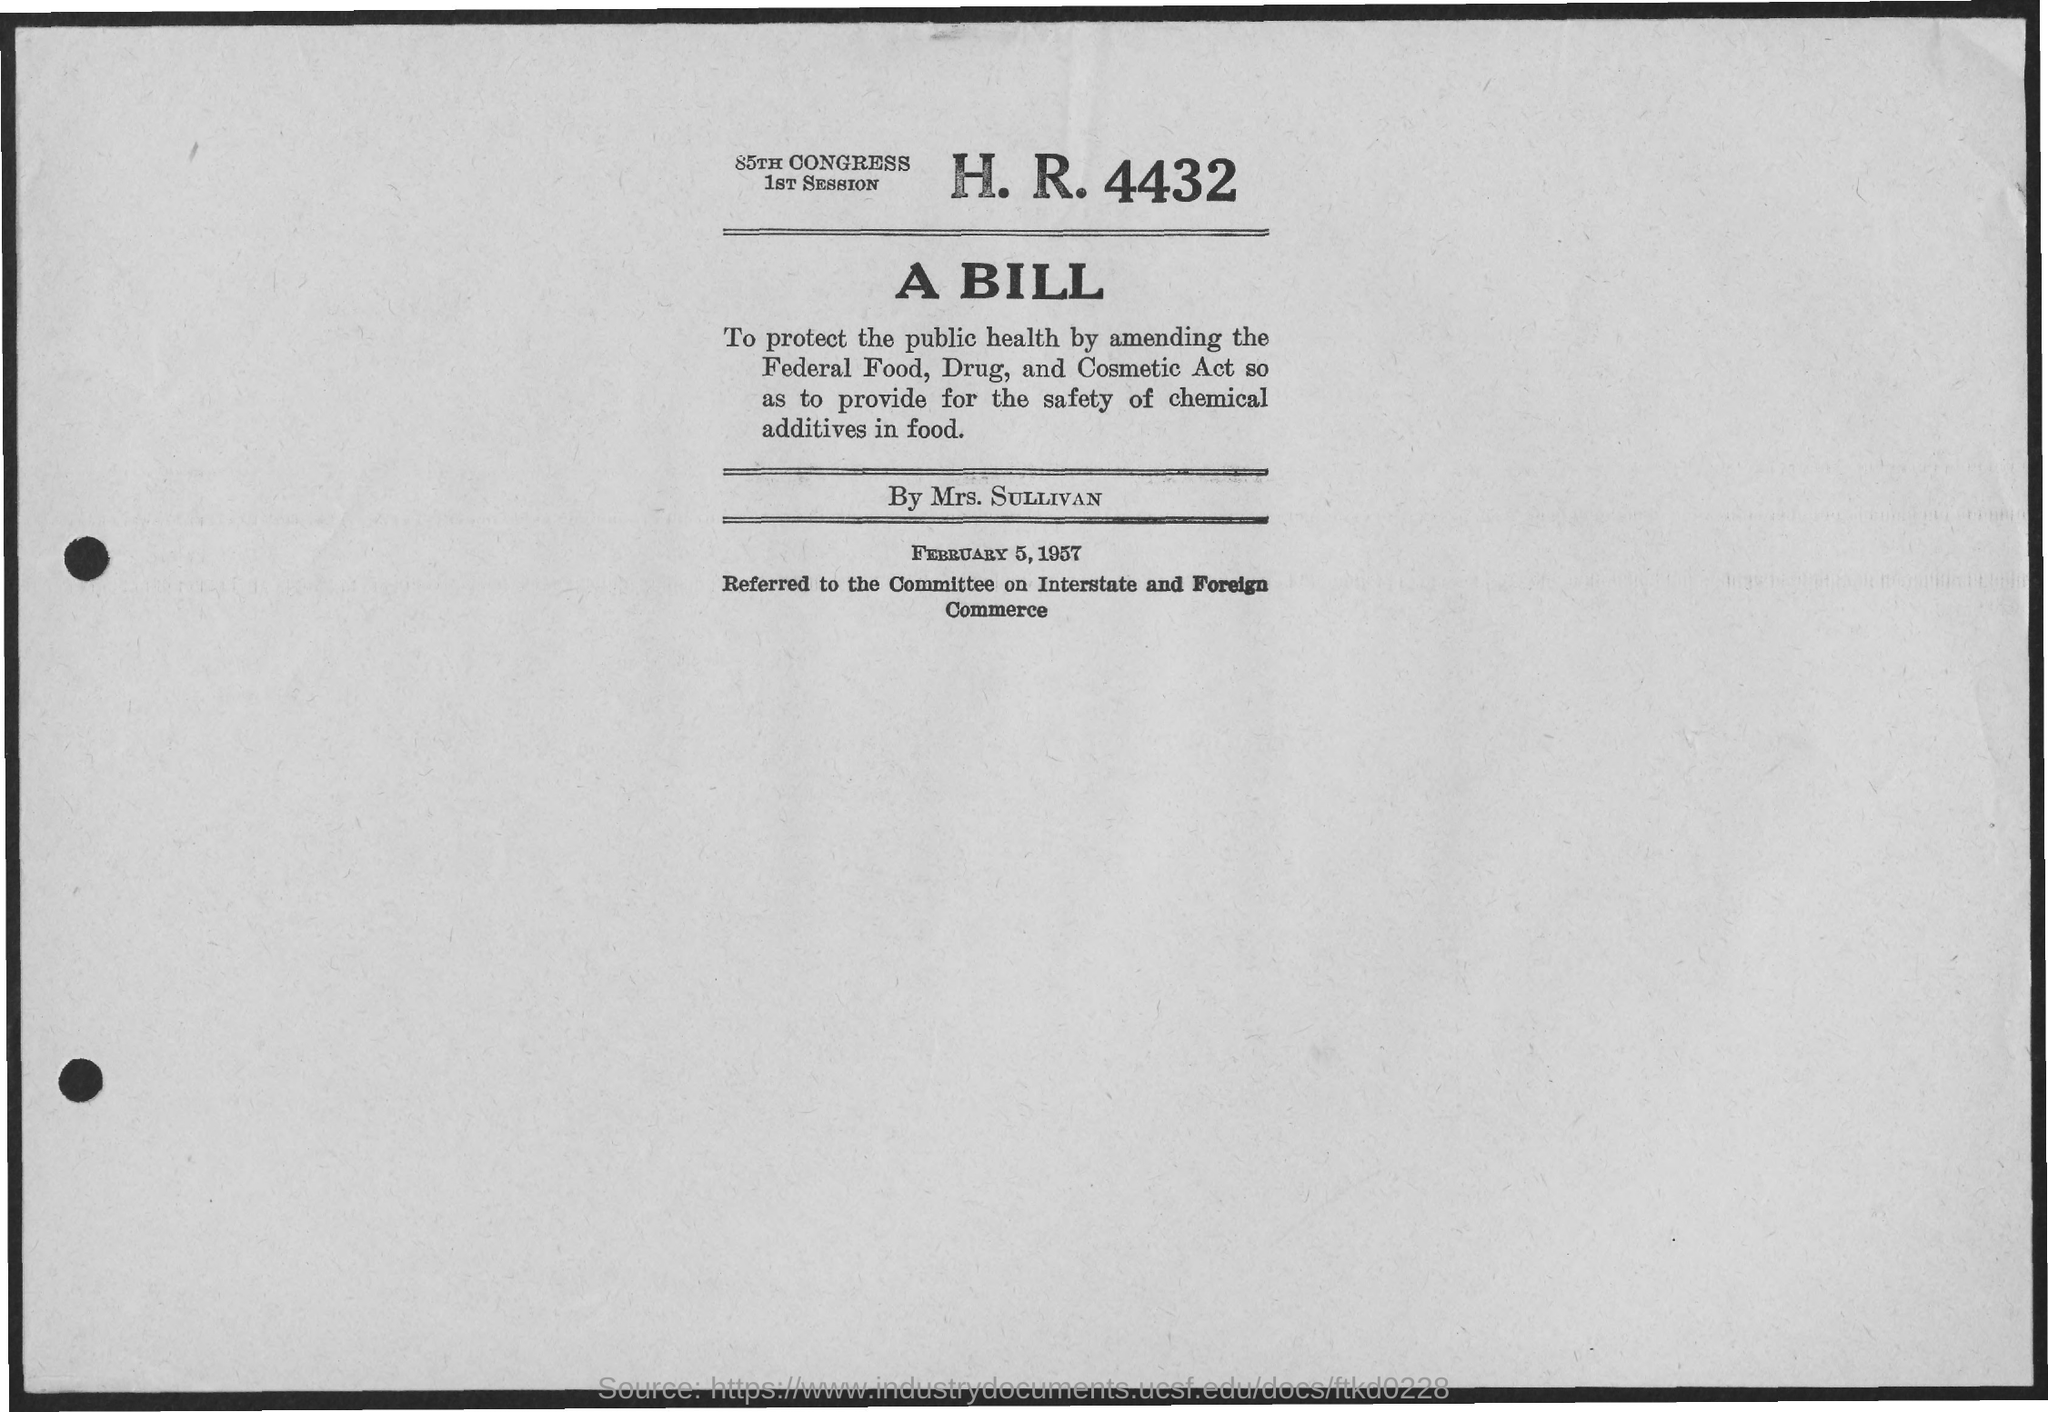What is the date on the document?
Offer a very short reply. FEBRUARY 5, 1957. A bill by whom?
Provide a short and direct response. Mrs. SULLIVAN. 